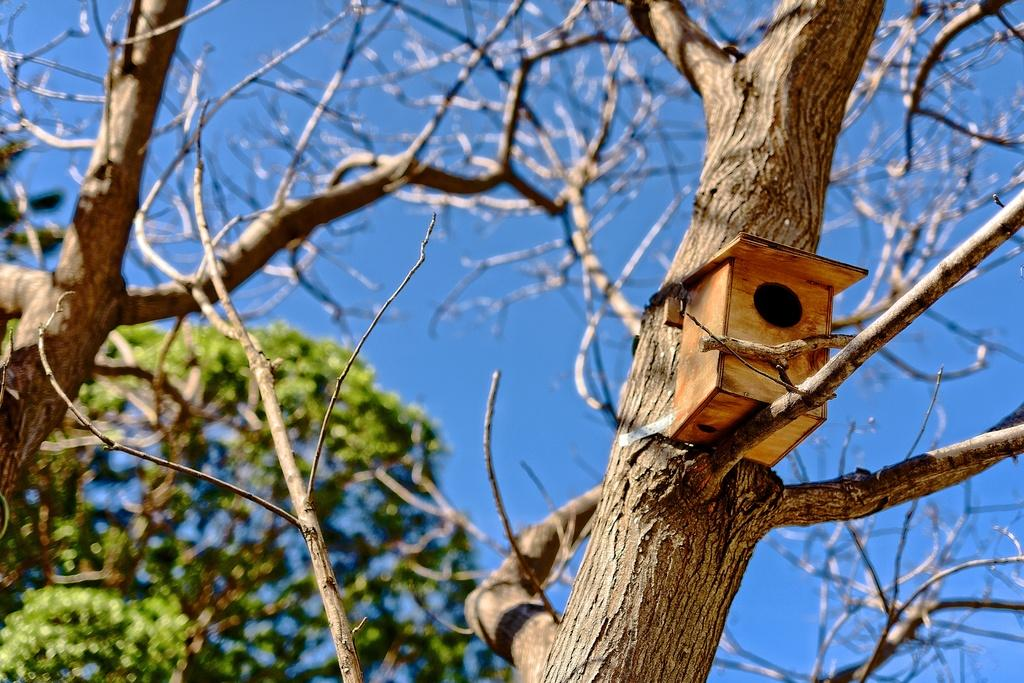What is the main object in the foreground of the picture? There is a tree in the picture. What is placed on one of the tree's branches? There is a wooden box on a branch of the tree. How would you describe the tree's structure? The tree has branches and twigs. What can be seen in the background of the picture? There is another tree in the background of the picture. How would you describe the weather based on the image? The sky is clear, suggesting good weather. What type of motion can be seen in the wooden box in the image? The wooden box is stationary on the tree branch, so there is no motion visible. What idea does the tree represent in the image? The image does not convey any specific ideas or concepts related to the tree; it is simply a tree with a wooden box on one of its branches. 